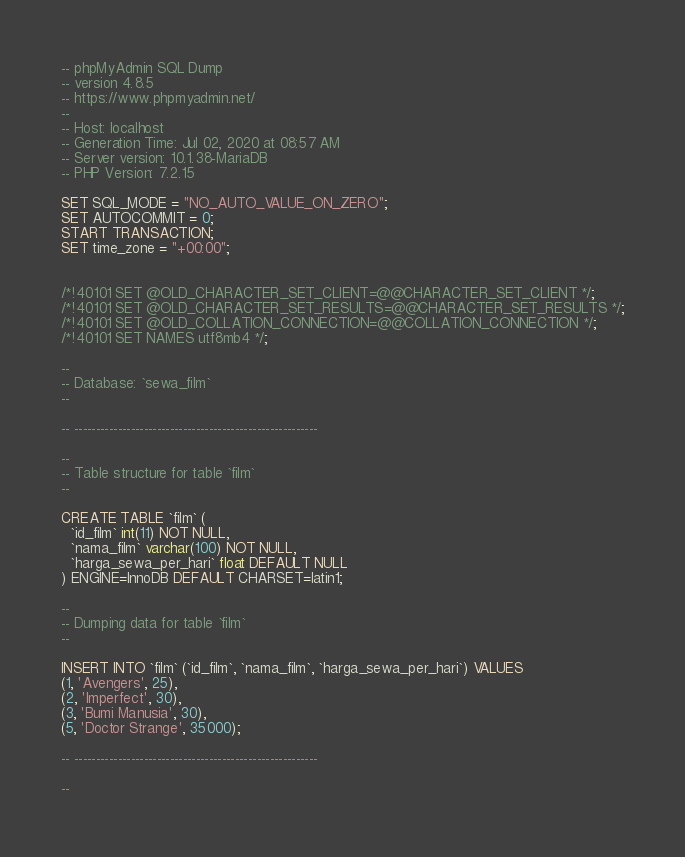<code> <loc_0><loc_0><loc_500><loc_500><_SQL_>-- phpMyAdmin SQL Dump
-- version 4.8.5
-- https://www.phpmyadmin.net/
--
-- Host: localhost
-- Generation Time: Jul 02, 2020 at 08:57 AM
-- Server version: 10.1.38-MariaDB
-- PHP Version: 7.2.15

SET SQL_MODE = "NO_AUTO_VALUE_ON_ZERO";
SET AUTOCOMMIT = 0;
START TRANSACTION;
SET time_zone = "+00:00";


/*!40101 SET @OLD_CHARACTER_SET_CLIENT=@@CHARACTER_SET_CLIENT */;
/*!40101 SET @OLD_CHARACTER_SET_RESULTS=@@CHARACTER_SET_RESULTS */;
/*!40101 SET @OLD_COLLATION_CONNECTION=@@COLLATION_CONNECTION */;
/*!40101 SET NAMES utf8mb4 */;

--
-- Database: `sewa_film`
--

-- --------------------------------------------------------

--
-- Table structure for table `film`
--

CREATE TABLE `film` (
  `id_film` int(11) NOT NULL,
  `nama_film` varchar(100) NOT NULL,
  `harga_sewa_per_hari` float DEFAULT NULL
) ENGINE=InnoDB DEFAULT CHARSET=latin1;

--
-- Dumping data for table `film`
--

INSERT INTO `film` (`id_film`, `nama_film`, `harga_sewa_per_hari`) VALUES
(1, 'Avengers', 25),
(2, 'Imperfect', 30),
(3, 'Bumi Manusia', 30),
(5, 'Doctor Strange', 35000);

-- --------------------------------------------------------

--</code> 